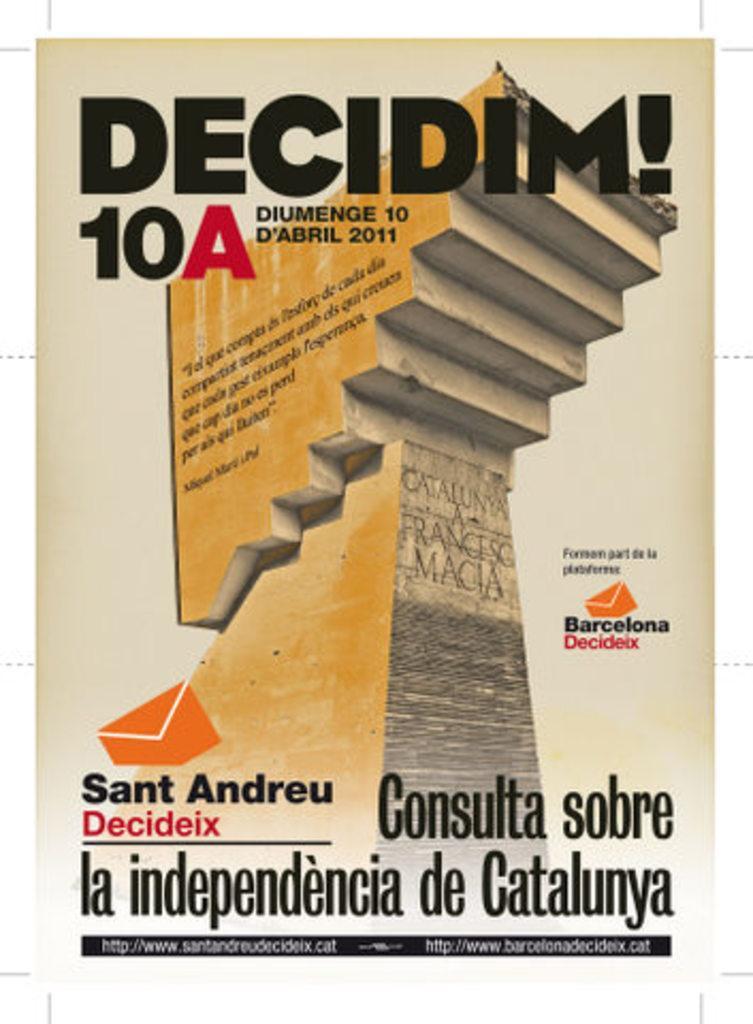In one or two sentences, can you explain what this image depicts? In this image is a front view of a book as we can see there is some text written at top of this image, some text at bottom of this image , and there is a picture of a stairs in middle of this image. 